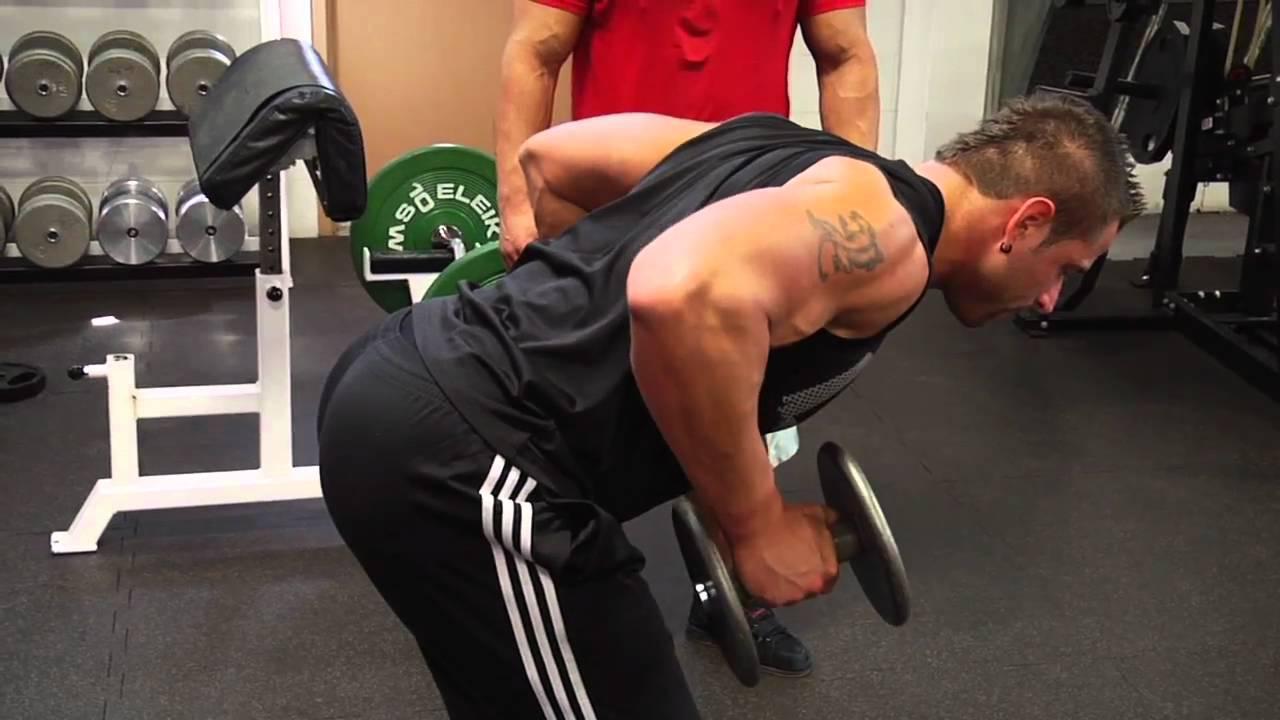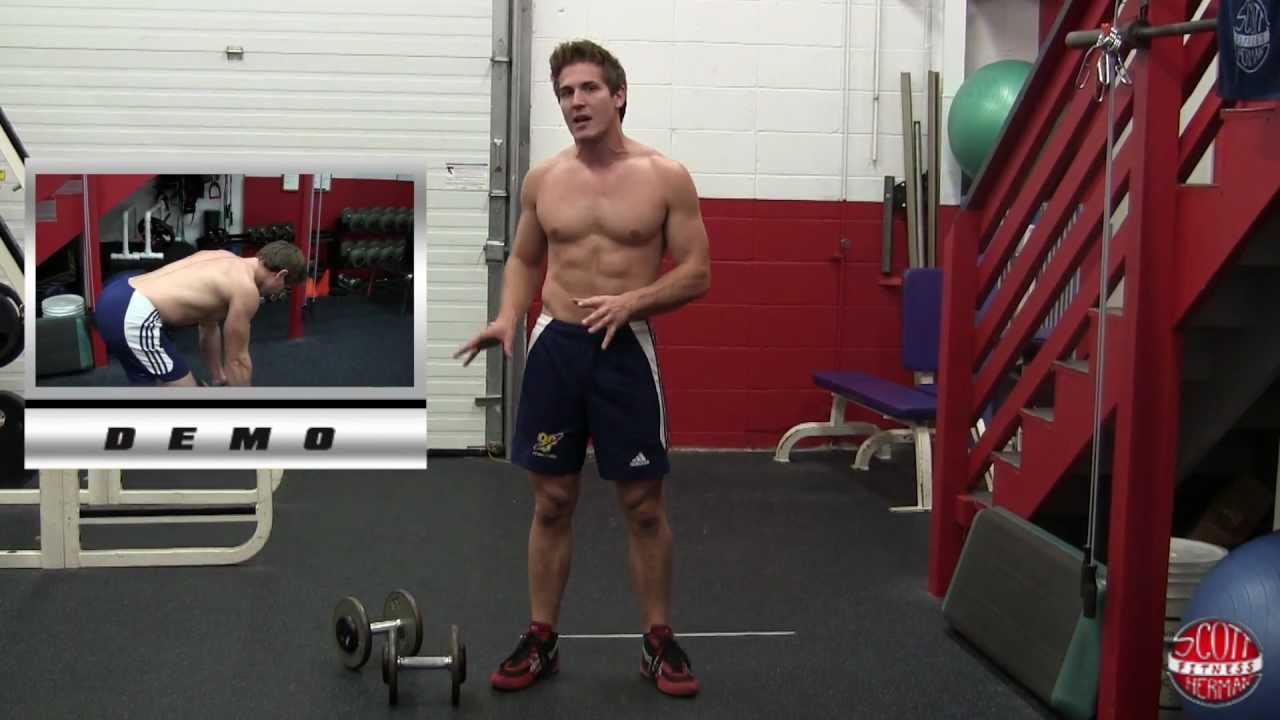The first image is the image on the left, the second image is the image on the right. Assess this claim about the two images: "Each image includes the same number of people, and each person is demonstrating the same type of workout and wearing the same attire.". Correct or not? Answer yes or no. No. The first image is the image on the left, the second image is the image on the right. Considering the images on both sides, is "There are at least two humans in the left image." valid? Answer yes or no. Yes. 